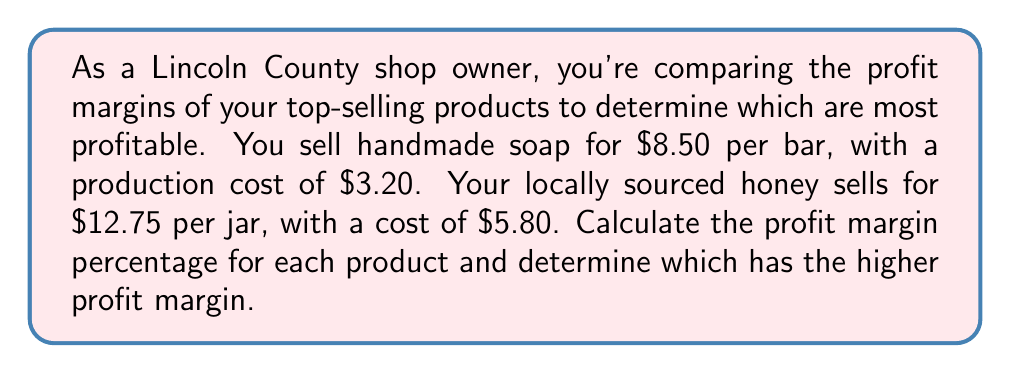Can you solve this math problem? To calculate the profit margin percentage, we'll use the formula:

$$\text{Profit Margin } \% = \frac{\text{Selling Price} - \text{Cost}}{\text{Selling Price}} \times 100\%$$

For the handmade soap:
1. Selling Price = $8.50
2. Cost = $3.20
3. Profit Margin % = $\frac{8.50 - 3.20}{8.50} \times 100\%$
4. $= \frac{5.30}{8.50} \times 100\%$
5. $\approx 62.35\%$

For the locally sourced honey:
1. Selling Price = $12.75
2. Cost = $5.80
3. Profit Margin % = $\frac{12.75 - 5.80}{12.75} \times 100\%$
4. $= \frac{6.95}{12.75} \times 100\%$
5. $\approx 54.51\%$

Comparing the two profit margins:
Handmade soap: 62.35%
Locally sourced honey: 54.51%

The handmade soap has a higher profit margin percentage.
Answer: Soap: 62.35%, Honey: 54.51%. Soap has higher margin. 